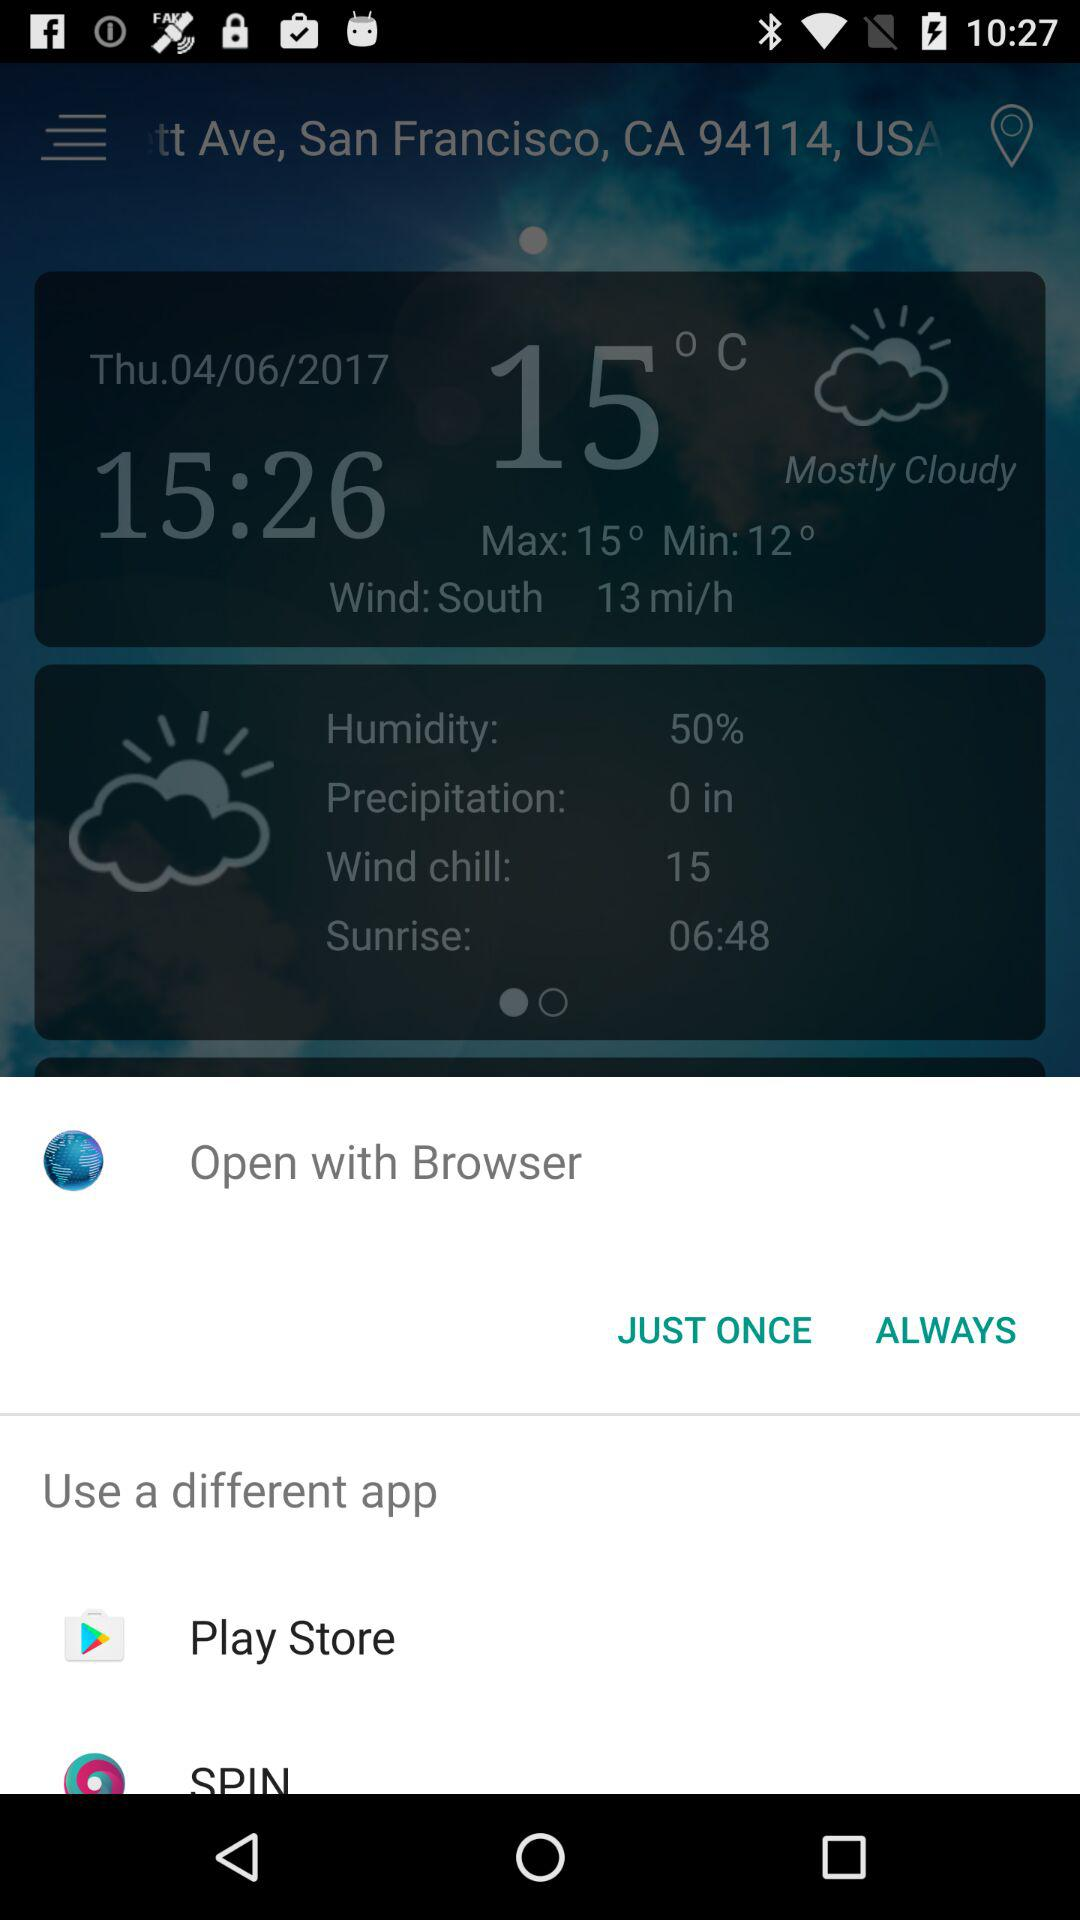What is the percentage of humidity? The percentage of humidity is 50. 